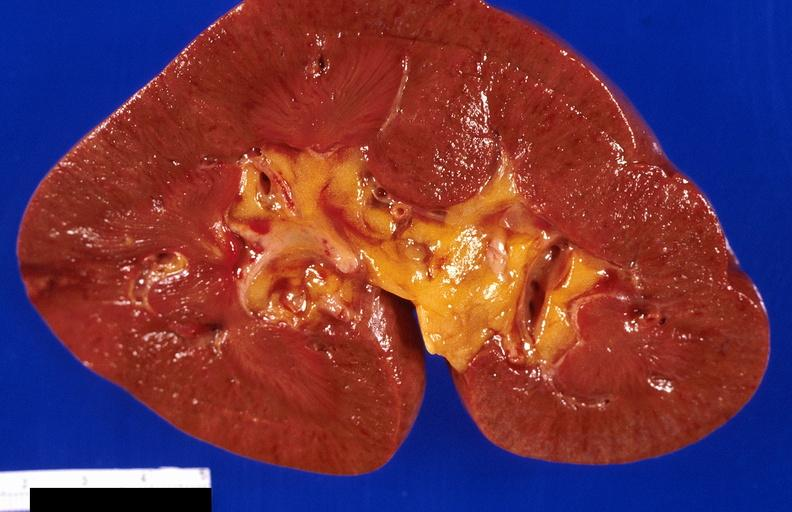where is this?
Answer the question using a single word or phrase. Urinary 